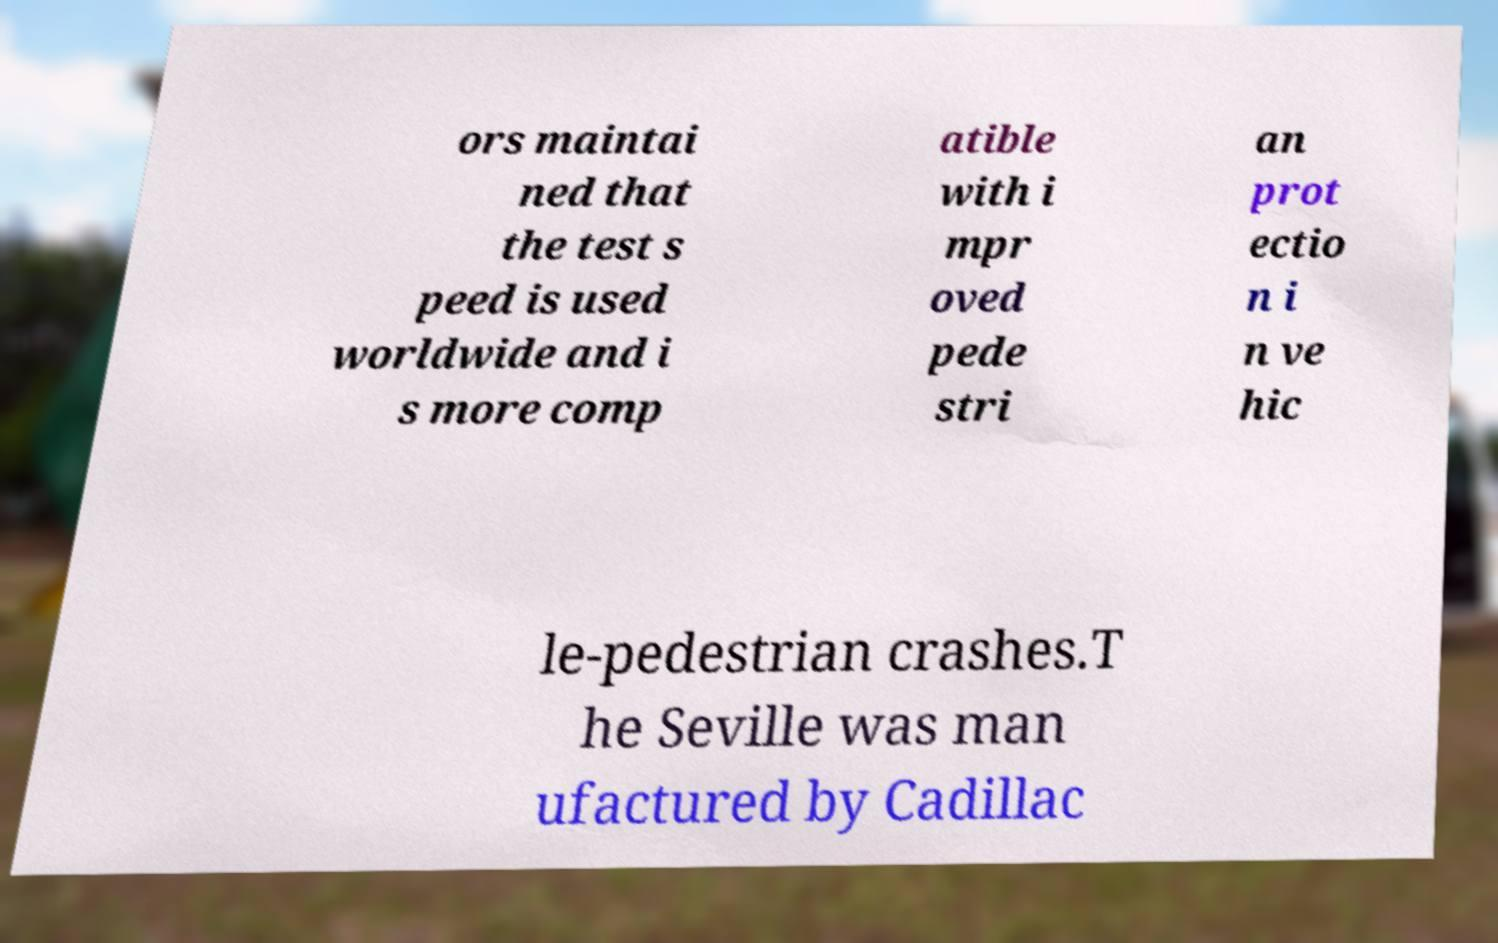For documentation purposes, I need the text within this image transcribed. Could you provide that? ors maintai ned that the test s peed is used worldwide and i s more comp atible with i mpr oved pede stri an prot ectio n i n ve hic le-pedestrian crashes.T he Seville was man ufactured by Cadillac 